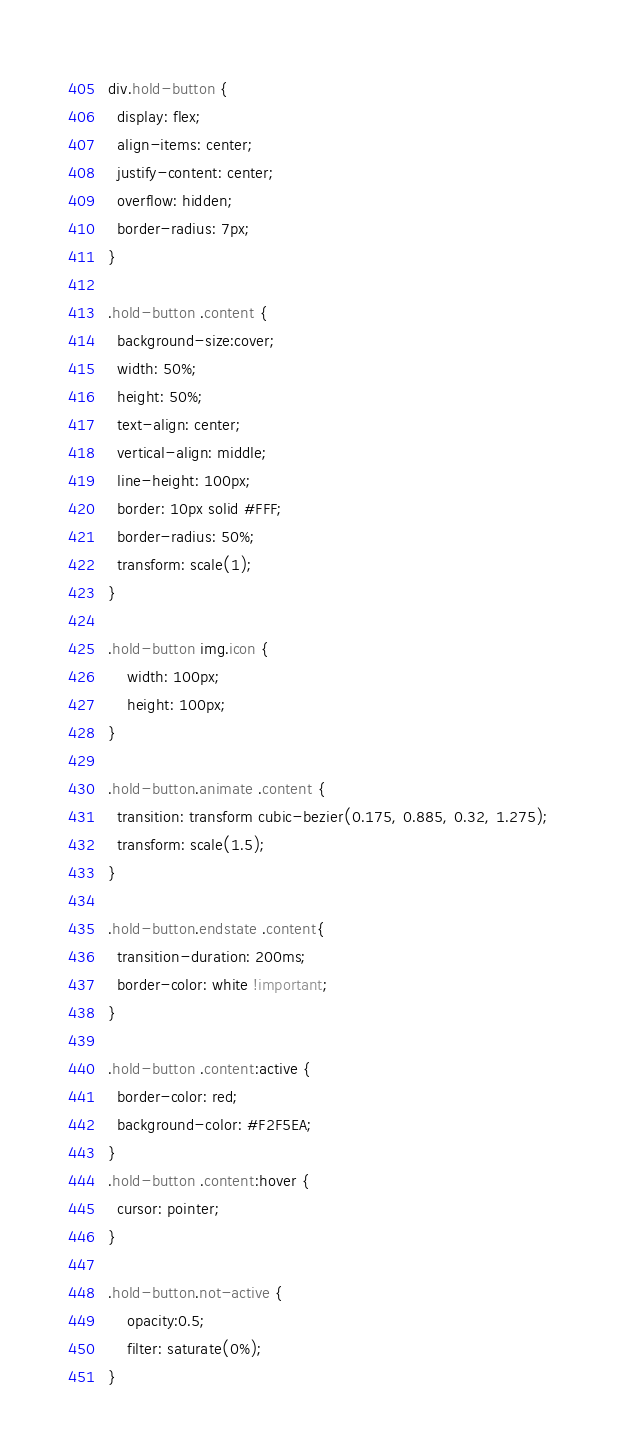Convert code to text. <code><loc_0><loc_0><loc_500><loc_500><_CSS_>div.hold-button {
  display: flex;
  align-items: center;
  justify-content: center;
  overflow: hidden;
  border-radius: 7px;
}

.hold-button .content {
  background-size:cover;
  width: 50%;
  height: 50%;
  text-align: center;
  vertical-align: middle;
  line-height: 100px;
  border: 10px solid #FFF;
  border-radius: 50%;
  transform: scale(1);
}

.hold-button img.icon {
    width: 100px;
    height: 100px;
}

.hold-button.animate .content {
  transition: transform cubic-bezier(0.175, 0.885, 0.32, 1.275);
  transform: scale(1.5);
}

.hold-button.endstate .content{
  transition-duration: 200ms;
  border-color: white !important;
}

.hold-button .content:active {
  border-color: red;
  background-color: #F2F5EA;
}
.hold-button .content:hover {
  cursor: pointer;
}

.hold-button.not-active {
    opacity:0.5;
    filter: saturate(0%);
}</code> 